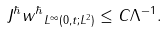<formula> <loc_0><loc_0><loc_500><loc_500>\| J ^ { \hbar } w ^ { \hbar } \| _ { L ^ { \infty } ( 0 , t ; L ^ { 2 } ) } \leq C \Lambda ^ { - 1 } .</formula> 